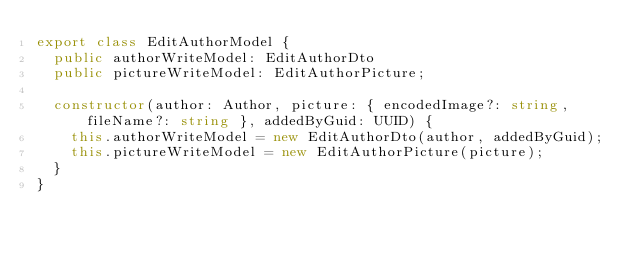Convert code to text. <code><loc_0><loc_0><loc_500><loc_500><_TypeScript_>export class EditAuthorModel {
  public authorWriteModel: EditAuthorDto
  public pictureWriteModel: EditAuthorPicture;

  constructor(author: Author, picture: { encodedImage?: string, fileName?: string }, addedByGuid: UUID) {
    this.authorWriteModel = new EditAuthorDto(author, addedByGuid);
    this.pictureWriteModel = new EditAuthorPicture(picture);
  }
}
</code> 